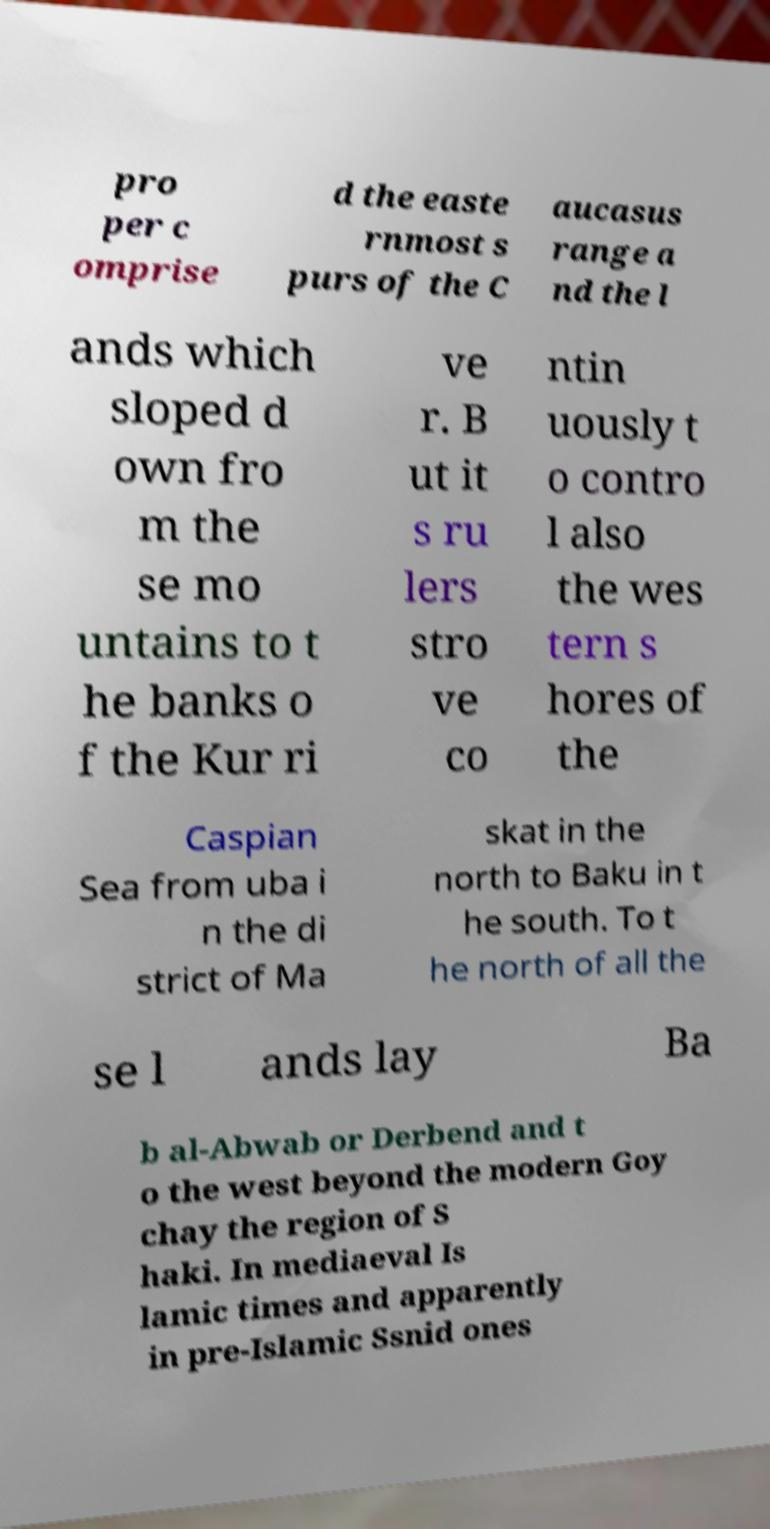Please read and relay the text visible in this image. What does it say? pro per c omprise d the easte rnmost s purs of the C aucasus range a nd the l ands which sloped d own fro m the se mo untains to t he banks o f the Kur ri ve r. B ut it s ru lers stro ve co ntin uously t o contro l also the wes tern s hores of the Caspian Sea from uba i n the di strict of Ma skat in the north to Baku in t he south. To t he north of all the se l ands lay Ba b al-Abwab or Derbend and t o the west beyond the modern Goy chay the region of S haki. In mediaeval Is lamic times and apparently in pre-Islamic Ssnid ones 